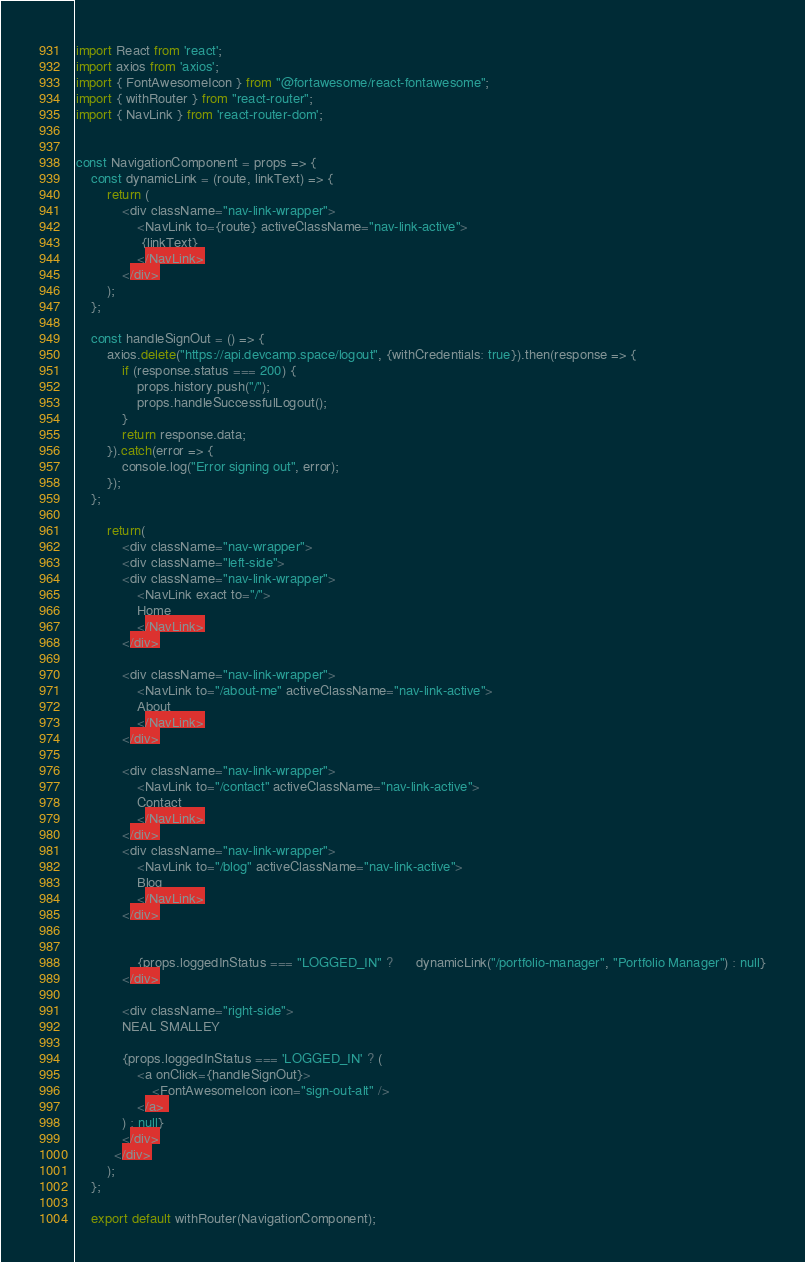Convert code to text. <code><loc_0><loc_0><loc_500><loc_500><_JavaScript_>import React from 'react';
import axios from 'axios';
import { FontAwesomeIcon } from "@fortawesome/react-fontawesome";
import { withRouter } from "react-router";
import { NavLink } from 'react-router-dom';


const NavigationComponent = props => {
    const dynamicLink = (route, linkText) => {
        return (
            <div className="nav-link-wrapper">
                <NavLink to={route} activeClassName="nav-link-active">
                 {linkText}
                </NavLink>
            </div>
        );
    };

    const handleSignOut = () => {
        axios.delete("https://api.devcamp.space/logout", {withCredentials: true}).then(response => {
            if (response.status === 200) {
                props.history.push("/");
                props.handleSuccessfulLogout();
            }
            return response.data;
        }).catch(error => {
            console.log("Error signing out", error);
        });
    };
            
        return(
            <div className="nav-wrapper">
            <div className="left-side">
            <div className="nav-link-wrapper">
                <NavLink exact to="/">
                Home
                </NavLink>
            </div>

            <div className="nav-link-wrapper">
                <NavLink to="/about-me" activeClassName="nav-link-active">
                About
                </NavLink>
            </div>

            <div className="nav-link-wrapper">
                <NavLink to="/contact" activeClassName="nav-link-active">
                Contact
                </NavLink>
            </div>
            <div className="nav-link-wrapper">
                <NavLink to="/blog" activeClassName="nav-link-active">
                Blog
                </NavLink>
            </div>


                {props.loggedInStatus === "LOGGED_IN" ?      dynamicLink("/portfolio-manager", "Portfolio Manager") : null}
            </div>

            <div className="right-side">
            NEAL SMALLEY

            {props.loggedInStatus === 'LOGGED_IN' ? (
                <a onClick={handleSignOut}>
                    <FontAwesomeIcon icon="sign-out-alt" />
                </a> 
            ) : null}
            </div>
          </div>
        );
    };

    export default withRouter(NavigationComponent);
</code> 